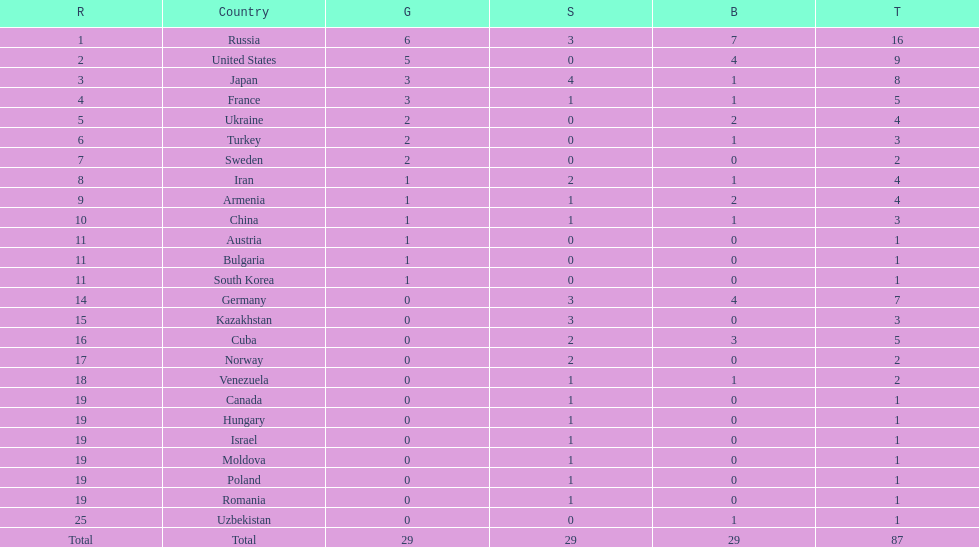Help me parse the entirety of this table. {'header': ['R', 'Country', 'G', 'S', 'B', 'T'], 'rows': [['1', 'Russia', '6', '3', '7', '16'], ['2', 'United States', '5', '0', '4', '9'], ['3', 'Japan', '3', '4', '1', '8'], ['4', 'France', '3', '1', '1', '5'], ['5', 'Ukraine', '2', '0', '2', '4'], ['6', 'Turkey', '2', '0', '1', '3'], ['7', 'Sweden', '2', '0', '0', '2'], ['8', 'Iran', '1', '2', '1', '4'], ['9', 'Armenia', '1', '1', '2', '4'], ['10', 'China', '1', '1', '1', '3'], ['11', 'Austria', '1', '0', '0', '1'], ['11', 'Bulgaria', '1', '0', '0', '1'], ['11', 'South Korea', '1', '0', '0', '1'], ['14', 'Germany', '0', '3', '4', '7'], ['15', 'Kazakhstan', '0', '3', '0', '3'], ['16', 'Cuba', '0', '2', '3', '5'], ['17', 'Norway', '0', '2', '0', '2'], ['18', 'Venezuela', '0', '1', '1', '2'], ['19', 'Canada', '0', '1', '0', '1'], ['19', 'Hungary', '0', '1', '0', '1'], ['19', 'Israel', '0', '1', '0', '1'], ['19', 'Moldova', '0', '1', '0', '1'], ['19', 'Poland', '0', '1', '0', '1'], ['19', 'Romania', '0', '1', '0', '1'], ['25', 'Uzbekistan', '0', '0', '1', '1'], ['Total', 'Total', '29', '29', '29', '87']]} How many combined gold medals did japan and france win? 6. 